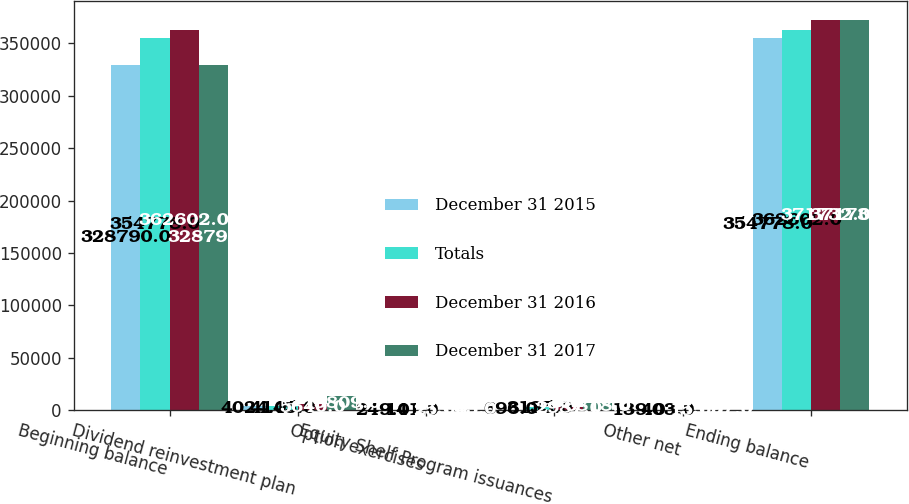Convert chart. <chart><loc_0><loc_0><loc_500><loc_500><stacked_bar_chart><ecel><fcel>Beginning balance<fcel>Dividend reinvestment plan<fcel>Option exercises<fcel>Equity Shelf Program issuances<fcel>Other net<fcel>Ending balance<nl><fcel>December 31 2015<fcel>328790<fcel>4024<fcel>249<fcel>696<fcel>139<fcel>354778<nl><fcel>Totals<fcel>354778<fcel>4145<fcel>141<fcel>3135<fcel>403<fcel>362602<nl><fcel>December 31 2016<fcel>362602<fcel>5640<fcel>253<fcel>2987<fcel>155<fcel>371732<nl><fcel>December 31 2017<fcel>328790<fcel>13809<fcel>643<fcel>6818<fcel>697<fcel>371732<nl></chart> 